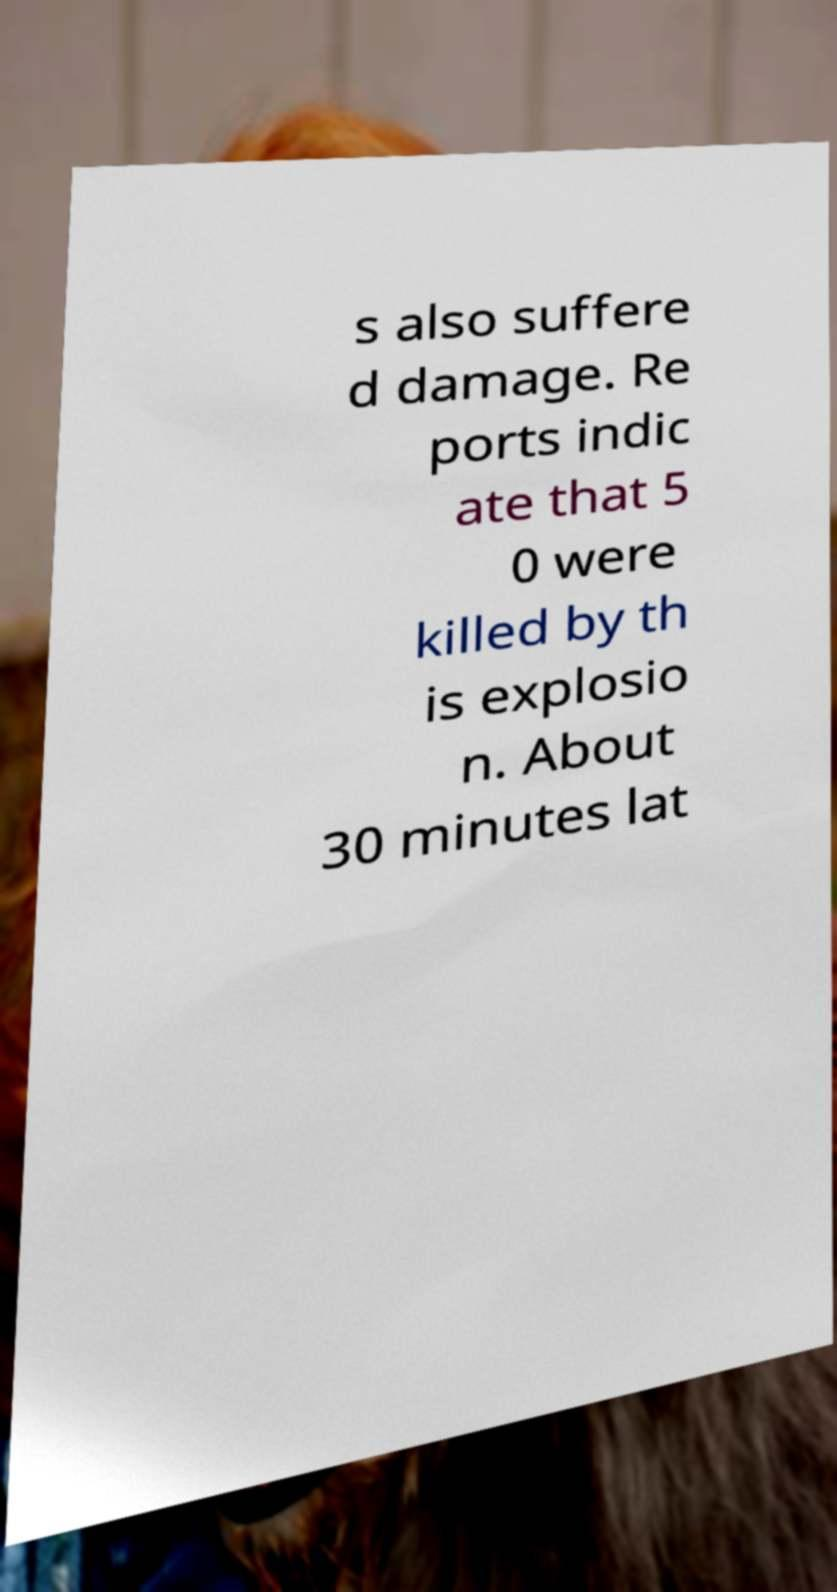Please read and relay the text visible in this image. What does it say? s also suffere d damage. Re ports indic ate that 5 0 were killed by th is explosio n. About 30 minutes lat 